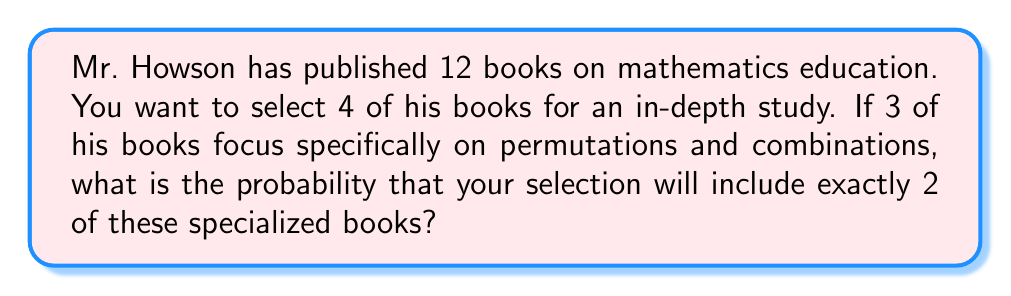Could you help me with this problem? Let's approach this step-by-step:

1) We need to use the combination formula to solve this problem. We'll calculate the number of favorable outcomes divided by the total number of possible outcomes.

2) Total number of ways to select 4 books out of 12:
   $$\binom{12}{4} = \frac{12!}{4!(12-4)!} = \frac{12!}{4!8!} = 495$$

3) Number of ways to select 2 books out of the 3 specialized books:
   $$\binom{3}{2} = \frac{3!}{2!(3-2)!} = \frac{3!}{2!1!} = 3$$

4) Number of ways to select 2 books out of the remaining 9 general books:
   $$\binom{9}{2} = \frac{9!}{2!(9-2)!} = \frac{9!}{2!7!} = 36$$

5) Total number of favorable outcomes:
   $$3 \times 36 = 108$$

6) Probability:
   $$P(\text{2 specialized books}) = \frac{\text{favorable outcomes}}{\text{total outcomes}} = \frac{108}{495}$$

7) Simplify the fraction:
   $$\frac{108}{495} = \frac{36}{165} = \frac{4}{55}$$
Answer: $\frac{4}{55}$ 